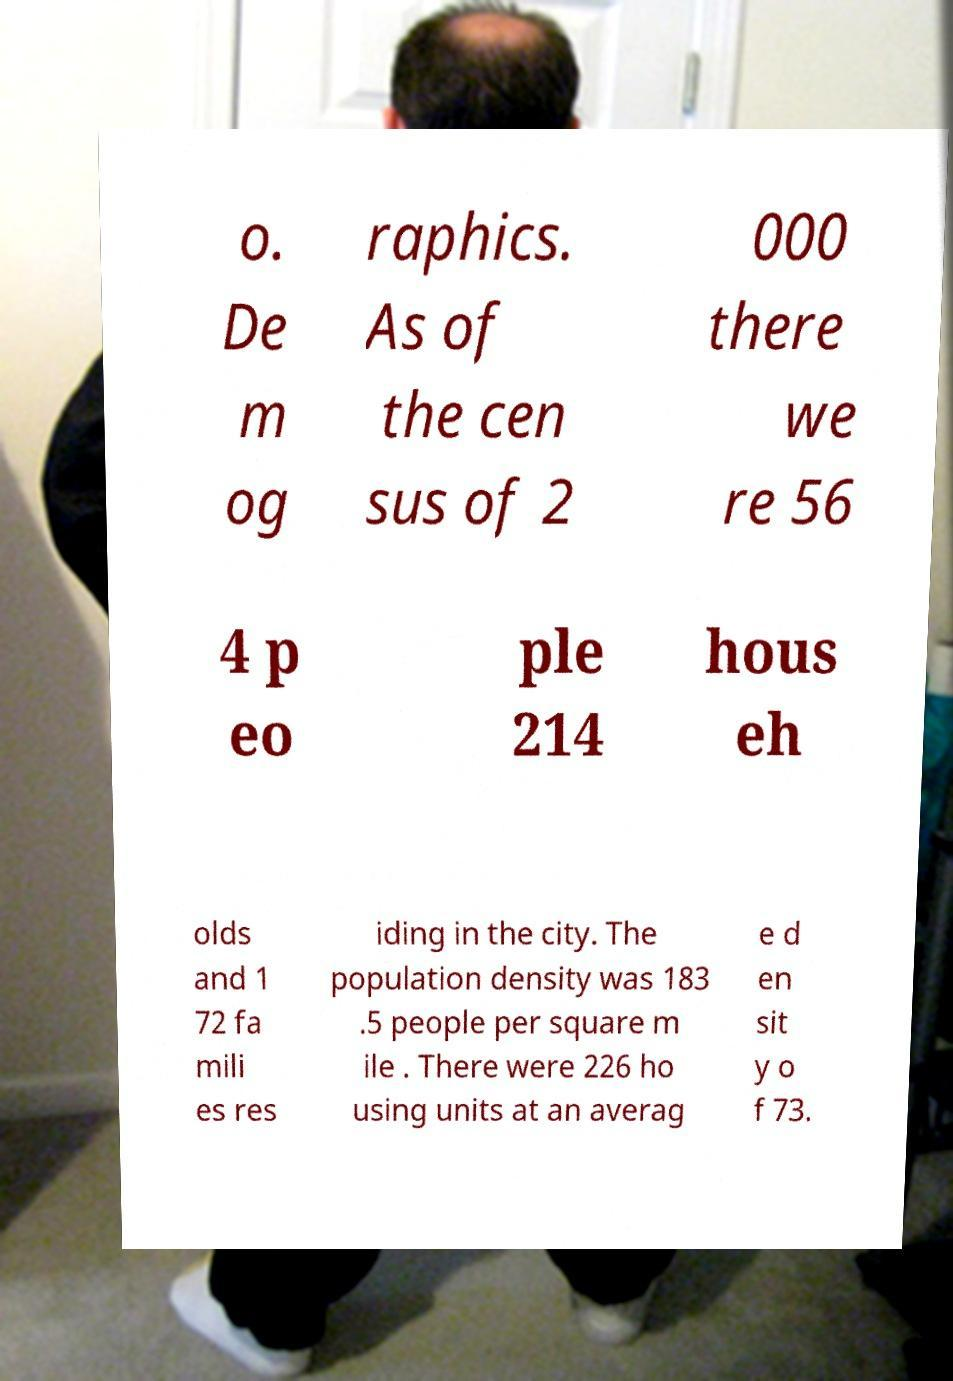Please identify and transcribe the text found in this image. o. De m og raphics. As of the cen sus of 2 000 there we re 56 4 p eo ple 214 hous eh olds and 1 72 fa mili es res iding in the city. The population density was 183 .5 people per square m ile . There were 226 ho using units at an averag e d en sit y o f 73. 